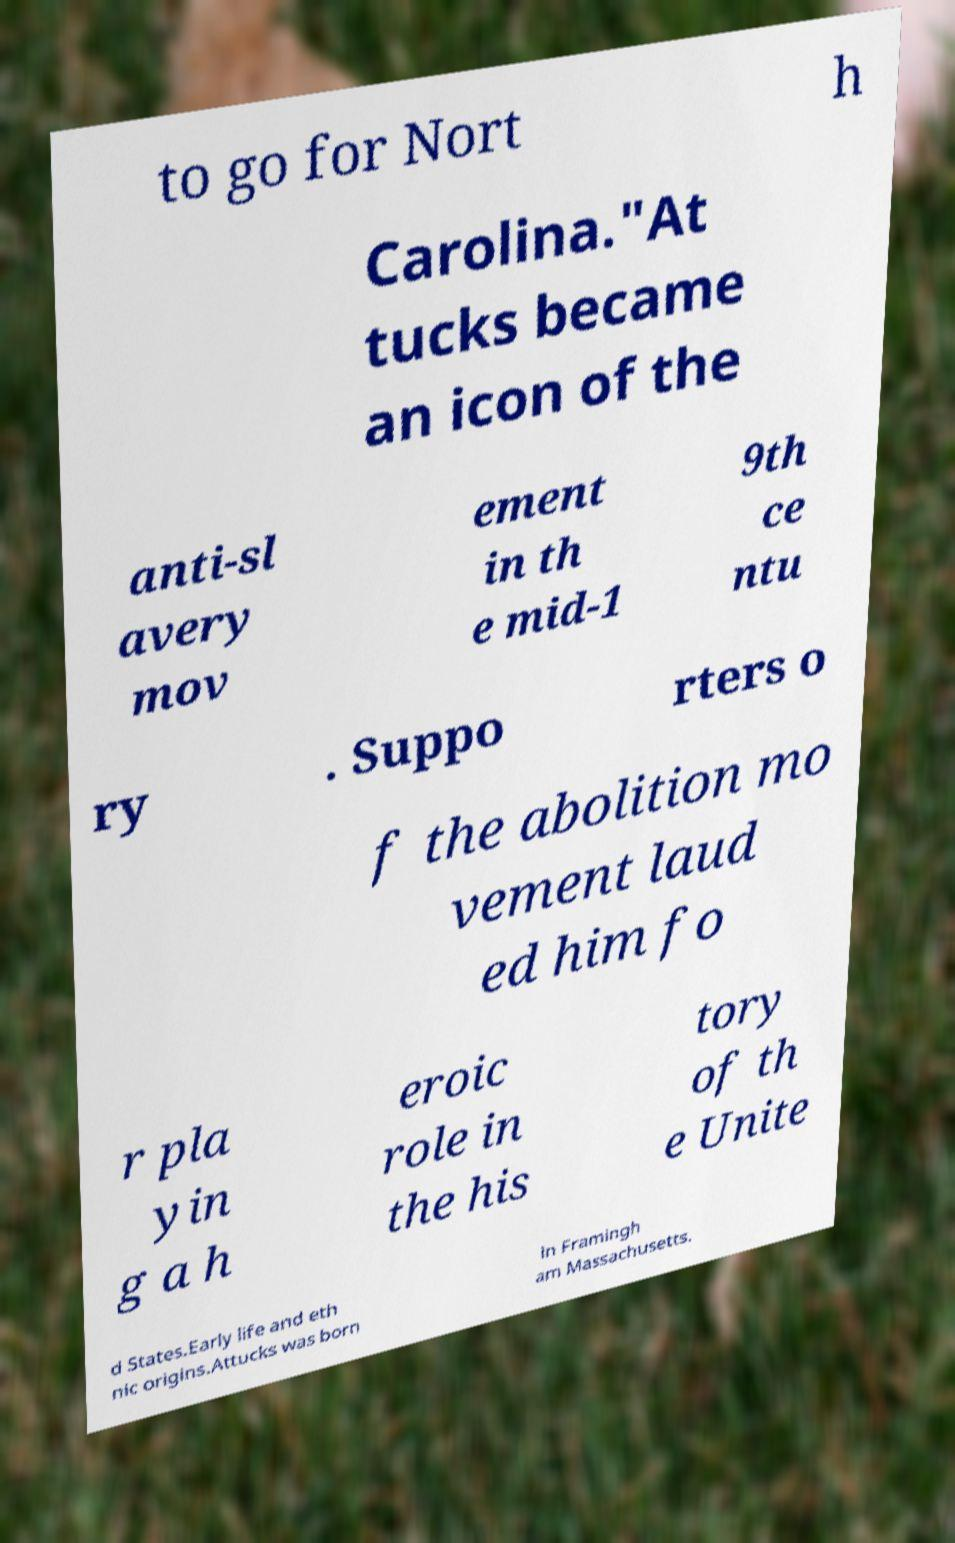Could you extract and type out the text from this image? to go for Nort h Carolina."At tucks became an icon of the anti-sl avery mov ement in th e mid-1 9th ce ntu ry . Suppo rters o f the abolition mo vement laud ed him fo r pla yin g a h eroic role in the his tory of th e Unite d States.Early life and eth nic origins.Attucks was born in Framingh am Massachusetts. 